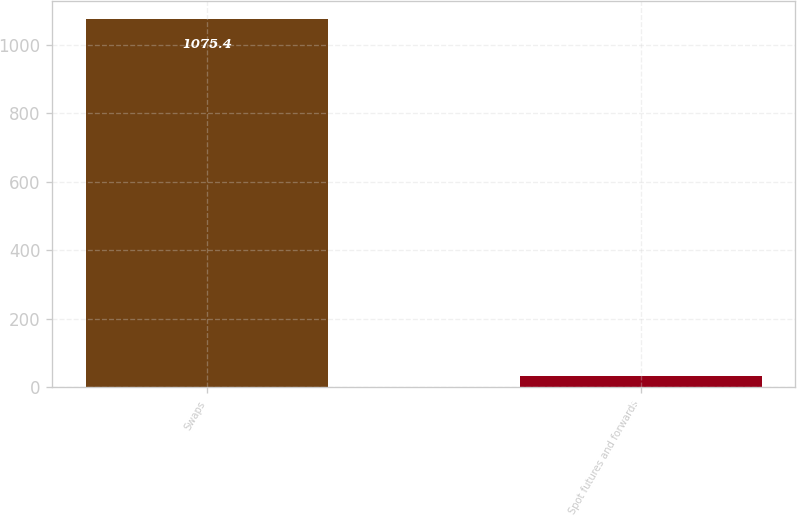<chart> <loc_0><loc_0><loc_500><loc_500><bar_chart><fcel>Swaps<fcel>Spot futures and forwards<nl><fcel>1075.4<fcel>31.5<nl></chart> 